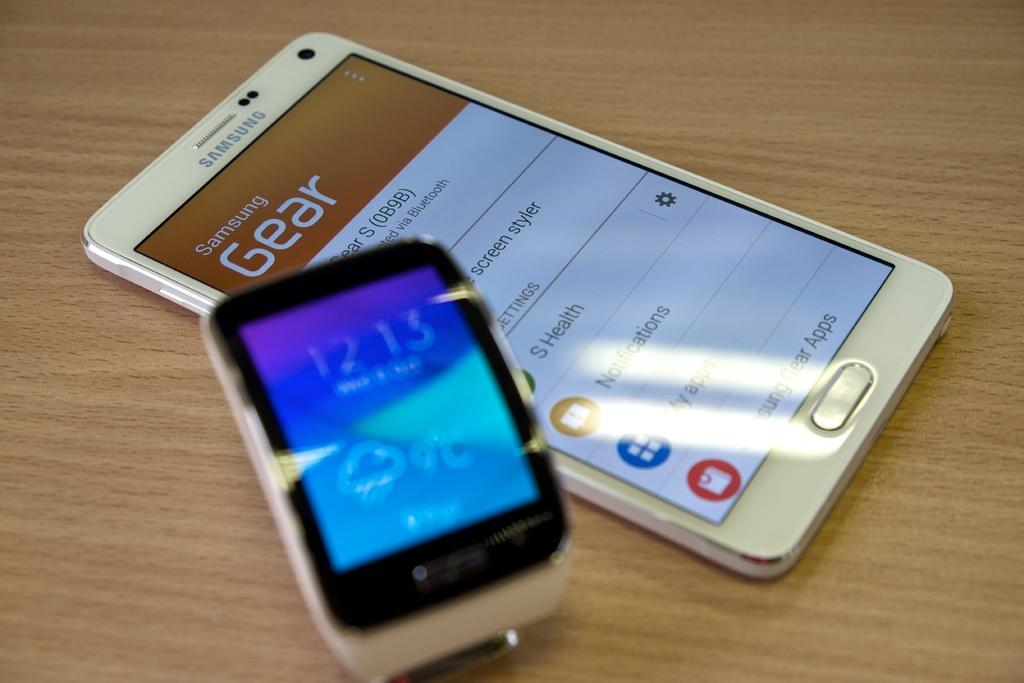<image>
Relay a brief, clear account of the picture shown. a white samsung phone with the screen on to a page that says 'samsung gear' on it 